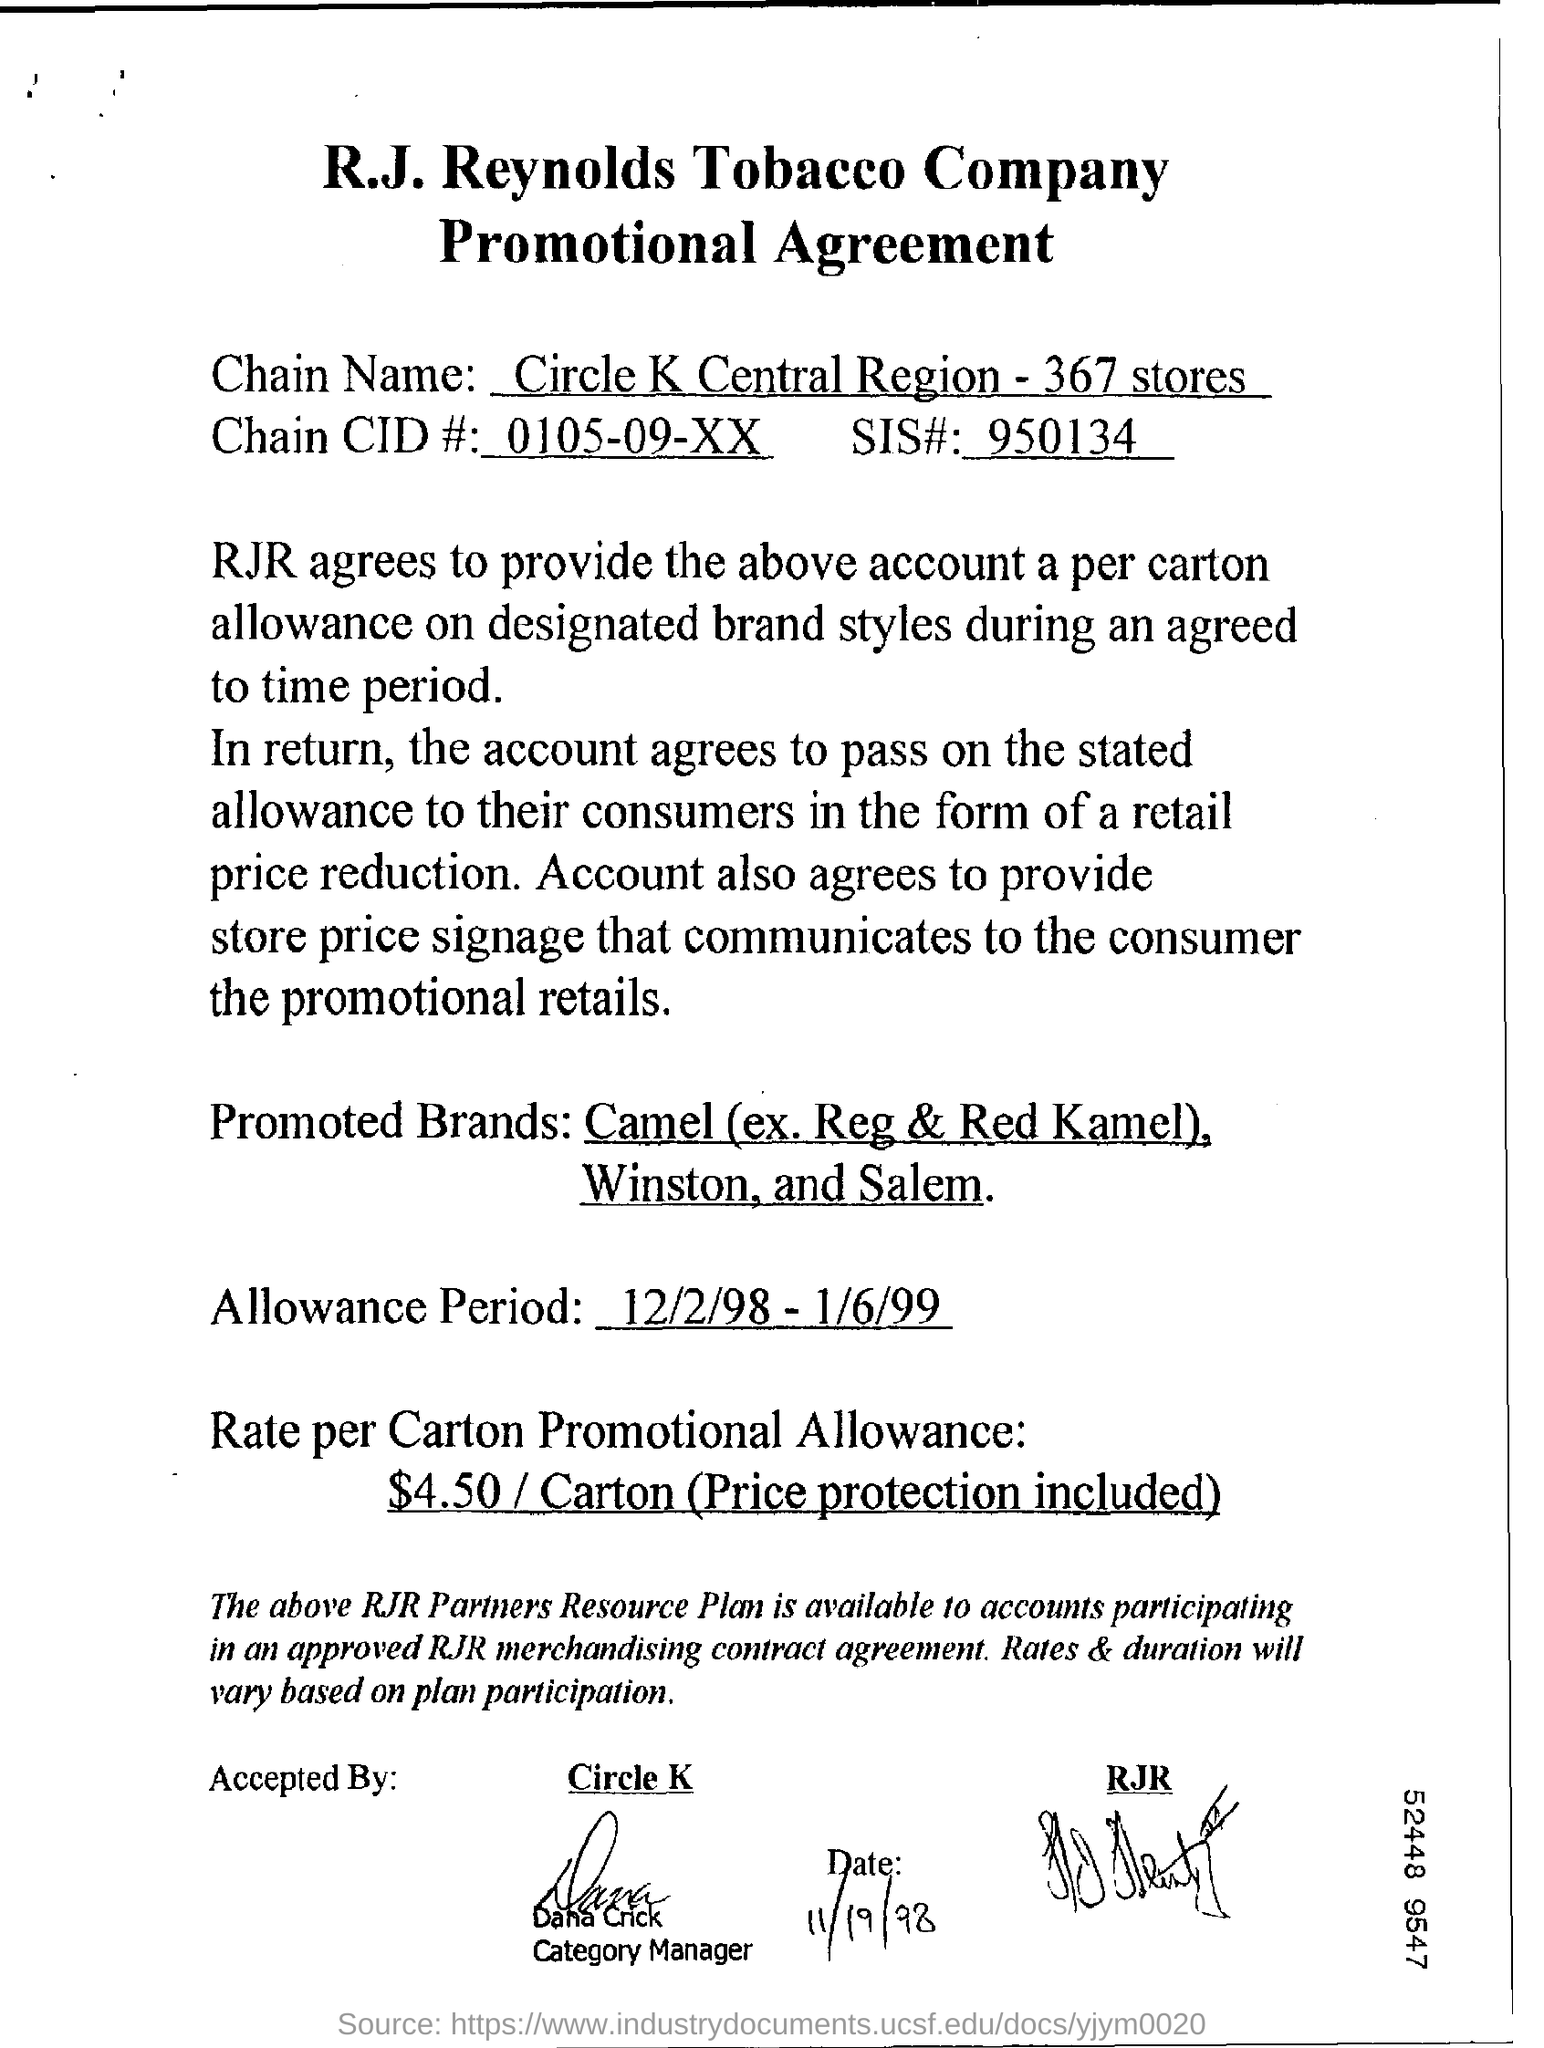Identify some key points in this picture. Dana Crick has been designated as the category manager. Circle K is a chain of convenience stores operating in the Central Region with 367 stores. R.J. Reynolds Tobacco Company entered into a promotional agreement. The number of SIS# is 950134...," which is a numerical notation used to represent a specific sequence of digits. The promotional allowance for each carton is $4.50, and price protection is included. 